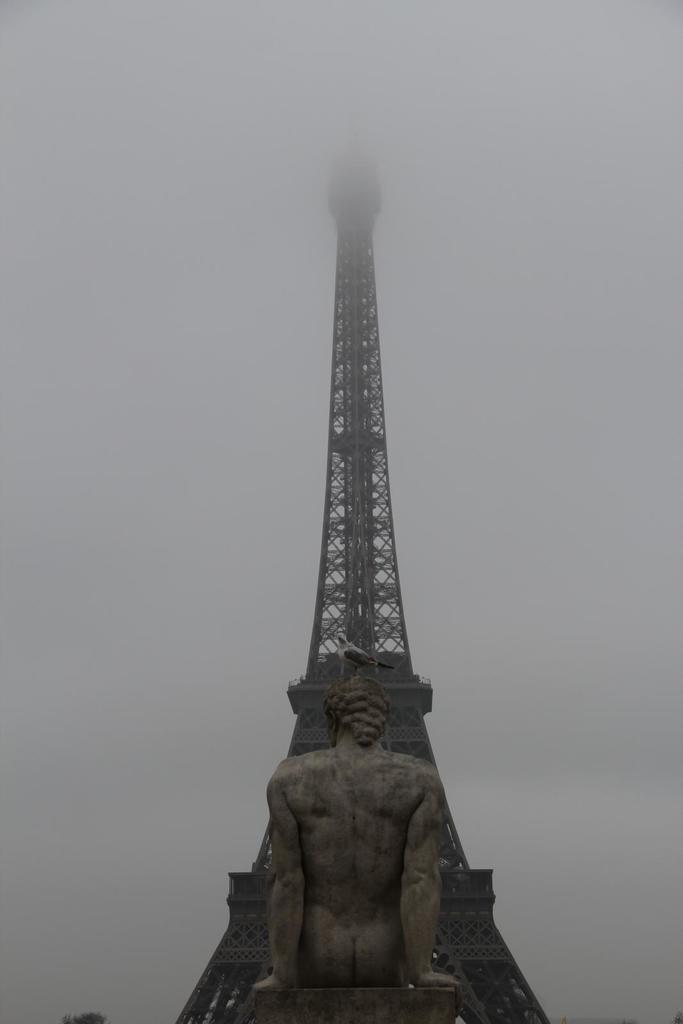Describe this image in one or two sentences. In this image there is a tower, in front of the tower there is a statue, on the statue there is a bird. In the background there is the sky. 